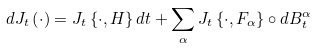<formula> <loc_0><loc_0><loc_500><loc_500>d J _ { t } \left ( \cdot \right ) = J _ { t } \left \{ \cdot , H \right \} d t + \sum _ { \alpha } J _ { t } \left \{ \cdot , F _ { \alpha } \right \} \circ d B _ { t } ^ { \alpha }</formula> 